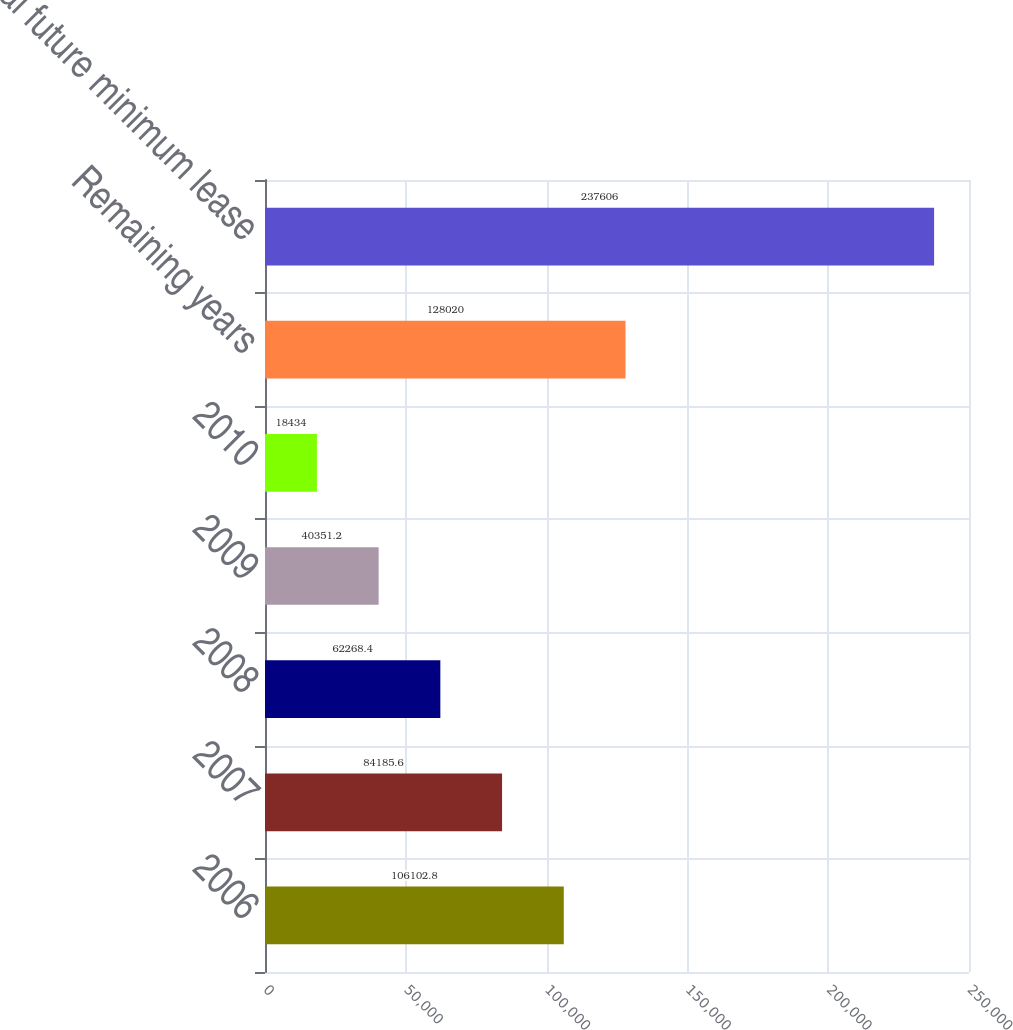Convert chart. <chart><loc_0><loc_0><loc_500><loc_500><bar_chart><fcel>2006<fcel>2007<fcel>2008<fcel>2009<fcel>2010<fcel>Remaining years<fcel>Total future minimum lease<nl><fcel>106103<fcel>84185.6<fcel>62268.4<fcel>40351.2<fcel>18434<fcel>128020<fcel>237606<nl></chart> 